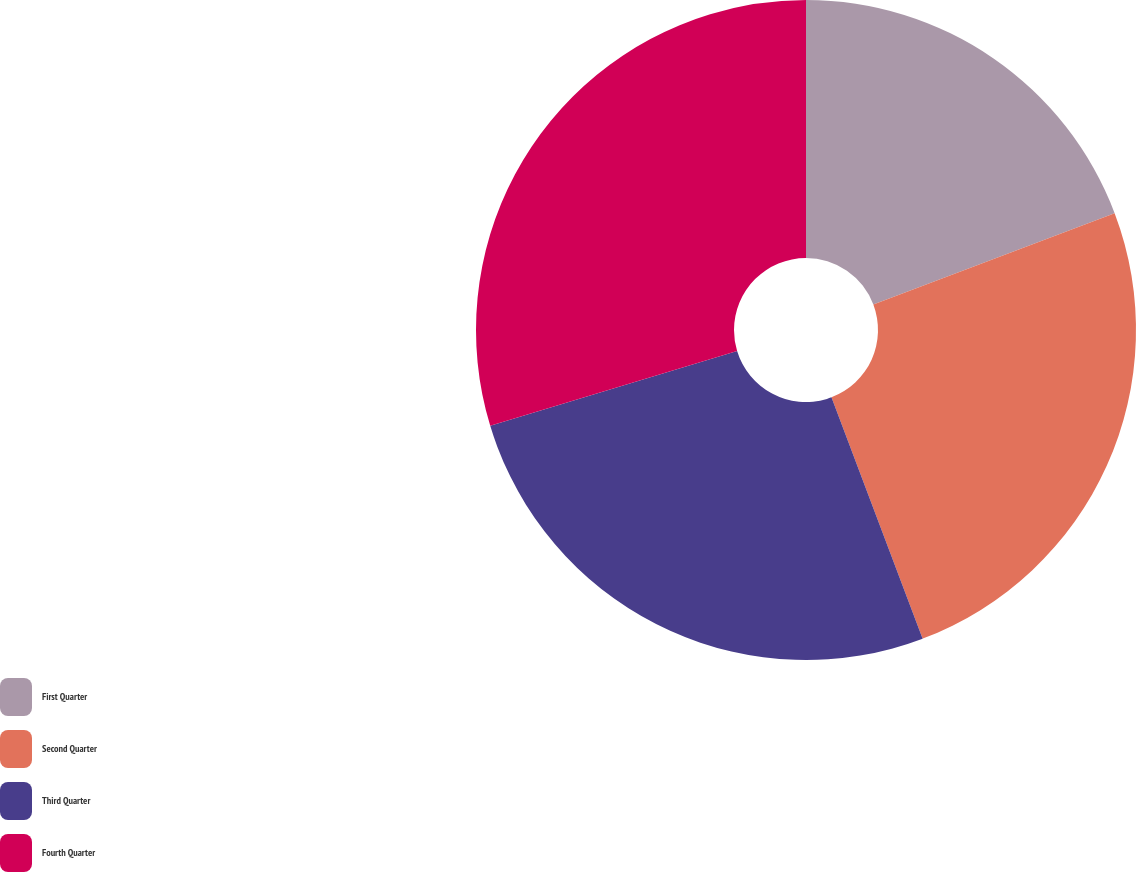<chart> <loc_0><loc_0><loc_500><loc_500><pie_chart><fcel>First Quarter<fcel>Second Quarter<fcel>Third Quarter<fcel>Fourth Quarter<nl><fcel>19.24%<fcel>25.01%<fcel>26.06%<fcel>29.69%<nl></chart> 